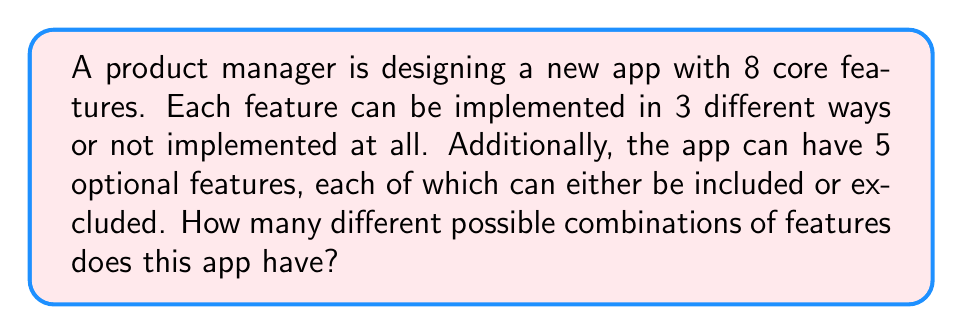Solve this math problem. Let's break this problem down step by step:

1) First, let's consider the core features:
   - Each core feature has 4 possibilities (3 implementation ways + 1 way of not implementing)
   - There are 8 core features
   - Therefore, the number of combinations for core features is $4^8$

2) Now, let's consider the optional features:
   - Each optional feature has 2 possibilities (included or excluded)
   - There are 5 optional features
   - Therefore, the number of combinations for optional features is $2^5$

3) According to the multiplication principle, to get the total number of combinations, we multiply the number of possibilities for core features with the number of possibilities for optional features:

   $$ \text{Total combinations} = 4^8 \times 2^5 $$

4) Let's calculate this:
   $$ 4^8 = 65,536 $$
   $$ 2^5 = 32 $$
   $$ 65,536 \times 32 = 2,097,152 $$

Therefore, there are 2,097,152 different possible combinations of features for this app.

This combinatorial approach allows the product manager to quickly estimate the vast number of possible app configurations, which can inform decisions about feature prioritization, testing strategies, and market positioning across different platforms.
Answer: 2,097,152 possible feature combinations 